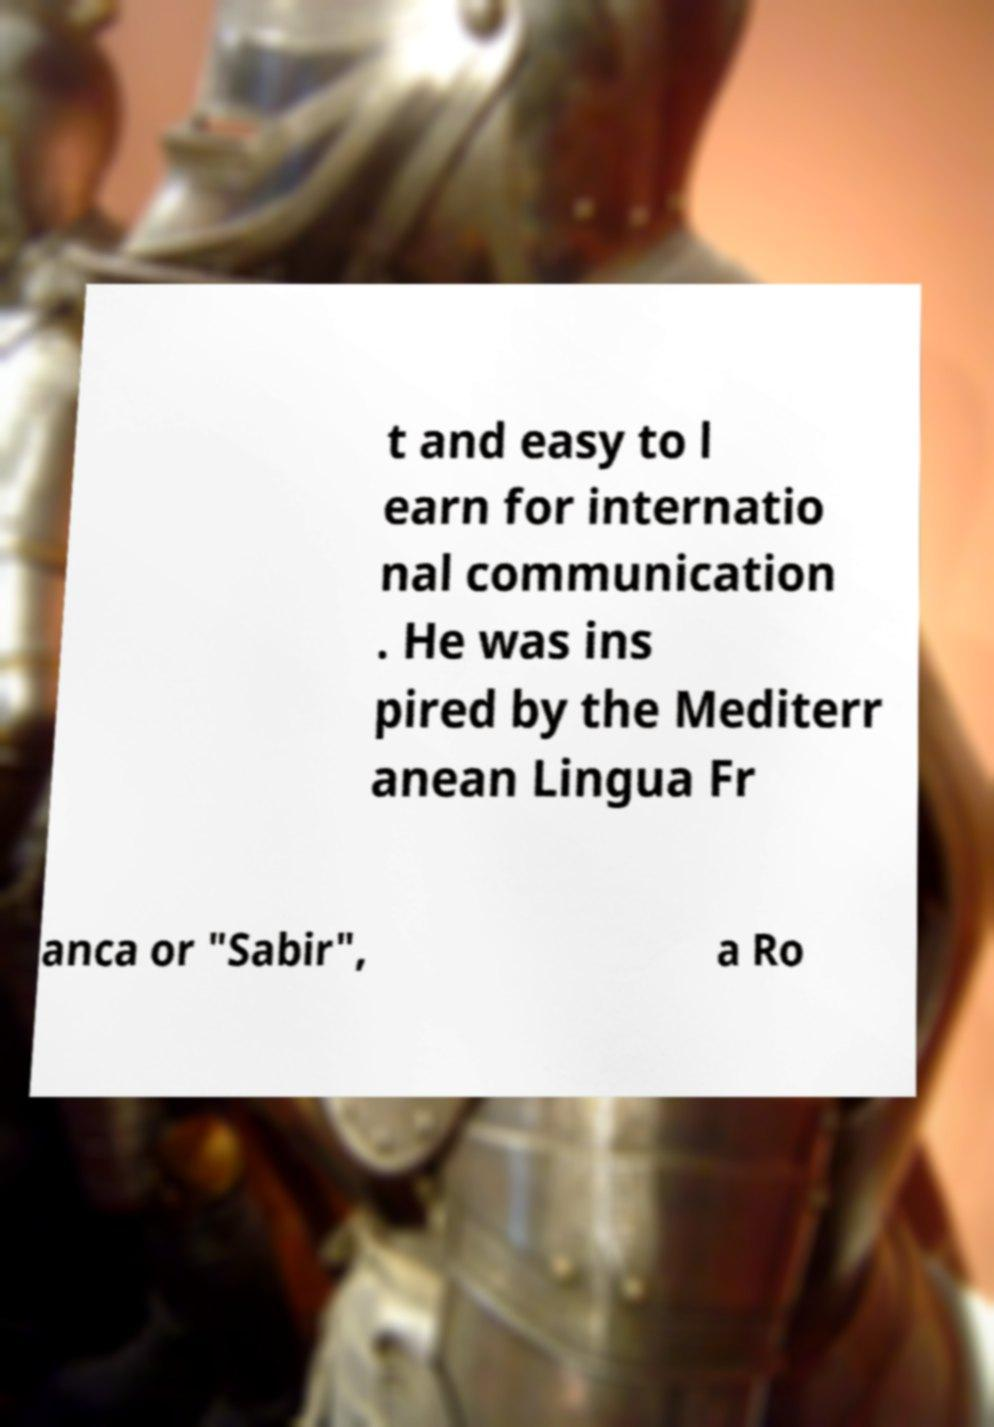Can you read and provide the text displayed in the image?This photo seems to have some interesting text. Can you extract and type it out for me? t and easy to l earn for internatio nal communication . He was ins pired by the Mediterr anean Lingua Fr anca or "Sabir", a Ro 